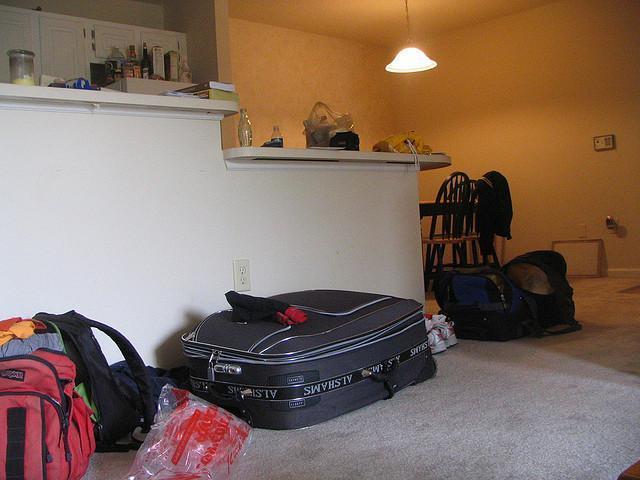How many chairs are there?
Give a very brief answer. 2. How many suitcases are there?
Give a very brief answer. 2. How many backpacks are there?
Give a very brief answer. 2. 